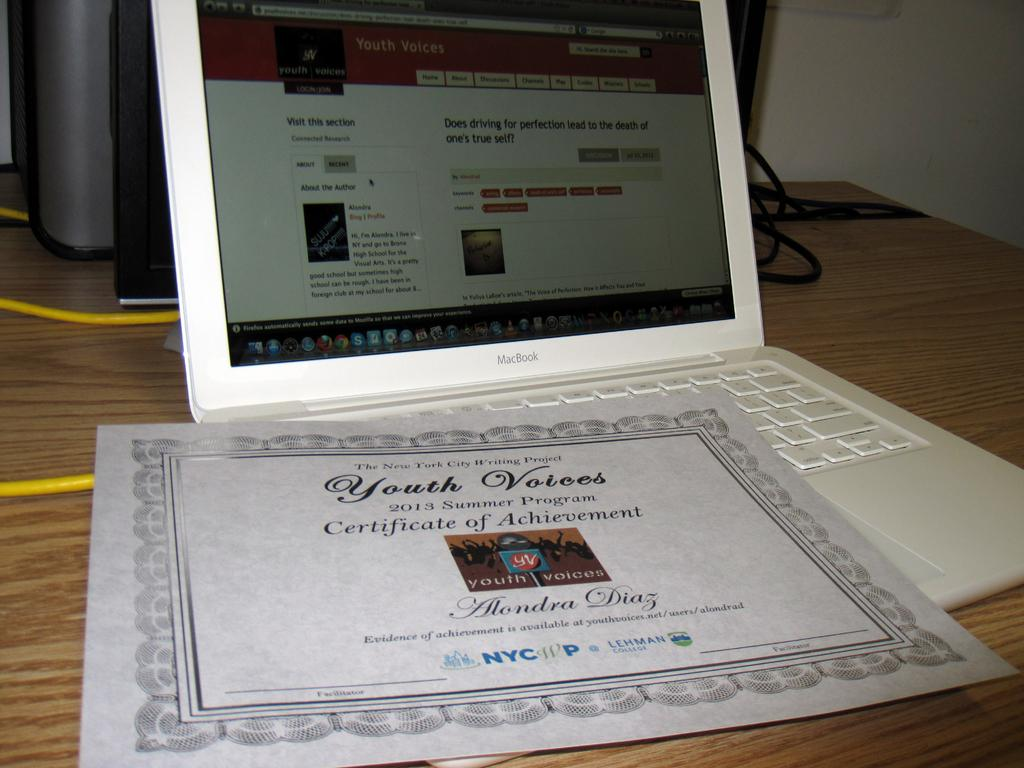<image>
Present a compact description of the photo's key features. Certificate of achievement for youth voices on a white laptop 